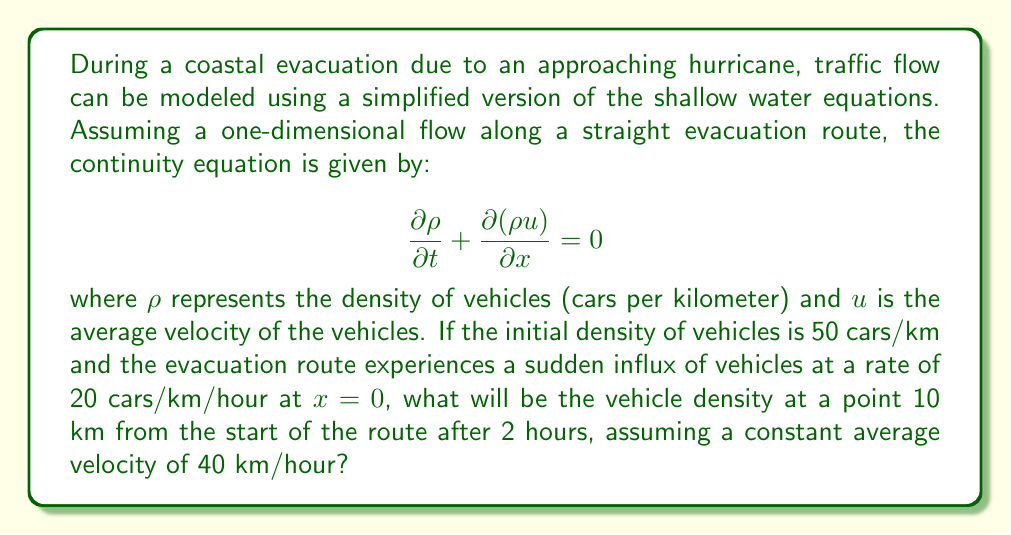Can you solve this math problem? To solve this problem, we need to use the method of characteristics for the given partial differential equation. The steps are as follows:

1) The characteristic curves for this equation are given by:

   $$\frac{dx}{dt} = u$$

   Since $u$ is constant at 40 km/hour, the characteristic curves are straight lines with slope 40 in the x-t plane.

2) Along these characteristics, the density $\rho$ remains constant. So we need to find the characteristic that passes through the point of interest (x = 10 km, t = 2 hours).

3) The equation of this characteristic is:

   $$x = 40t + x_0$$

   where $x_0$ is the starting point of the characteristic at t = 0.

4) Substituting our point of interest:

   $$10 = 40(2) + x_0$$
   $$x_0 = 10 - 80 = -70$$

5) This means the characteristic passing through our point of interest starts 70 km before the beginning of our route at t = 0.

6) Since this point is outside our domain (before the start of the route), we need to find where this characteristic intersects the t-axis (x = 0). This occurs at:

   $$0 = 40t - 70$$
   $$t = 1.75 \text{ hours}$$

7) At this point (x = 0, t = 1.75 hours), the density is:

   $$\rho = 50 + 20 * 1.75 = 85 \text{ cars/km}$$

8) This density will remain constant along the characteristic, so this is the density at our point of interest (x = 10 km, t = 2 hours).
Answer: The vehicle density at a point 10 km from the start of the route after 2 hours will be 85 cars/km. 